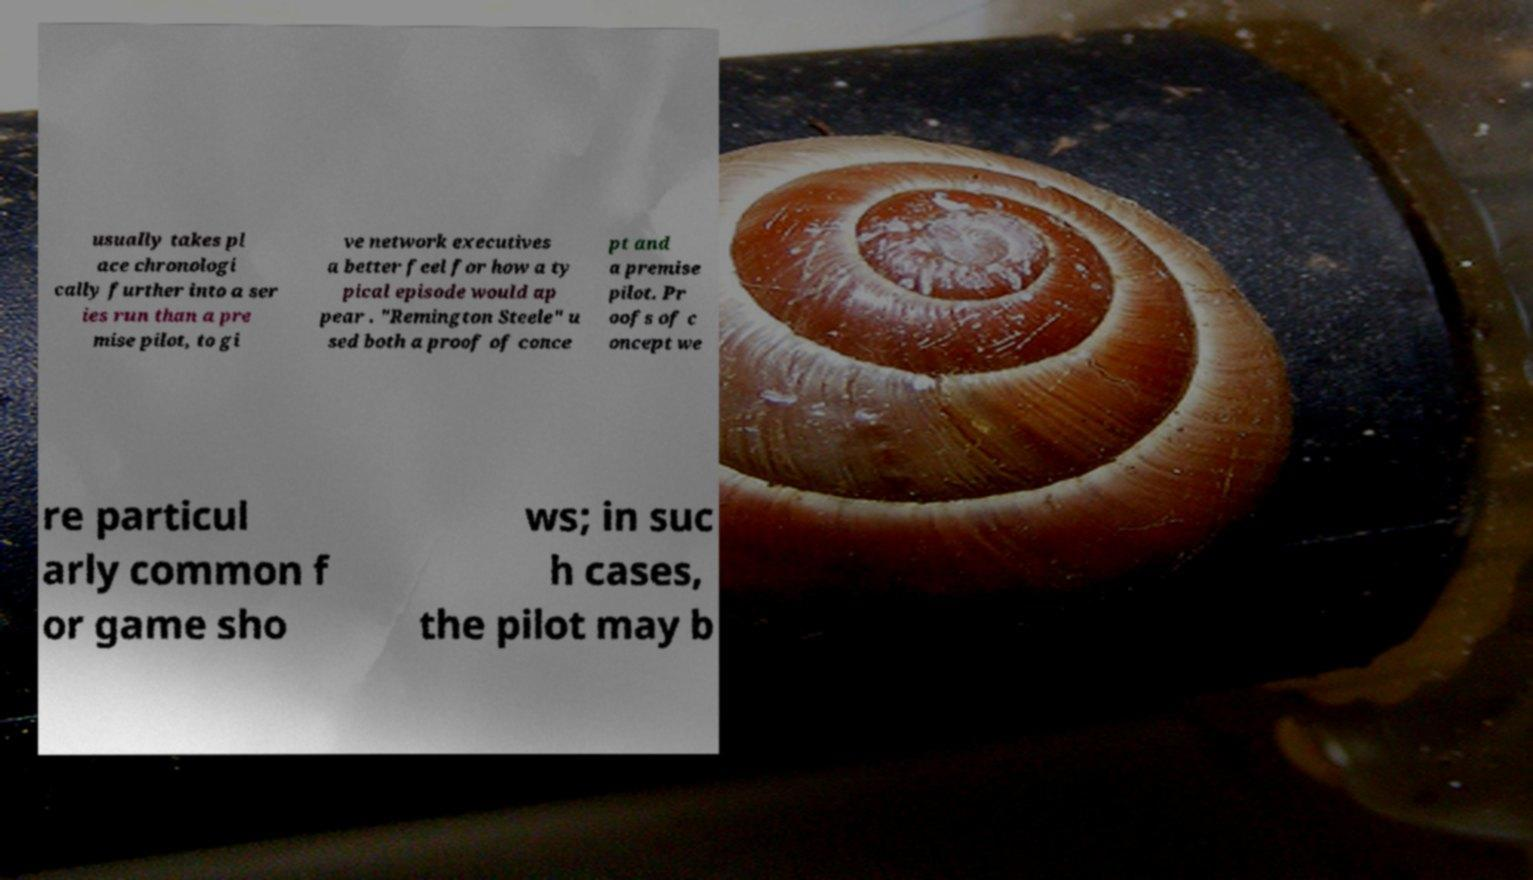Please read and relay the text visible in this image. What does it say? usually takes pl ace chronologi cally further into a ser ies run than a pre mise pilot, to gi ve network executives a better feel for how a ty pical episode would ap pear . "Remington Steele" u sed both a proof of conce pt and a premise pilot. Pr oofs of c oncept we re particul arly common f or game sho ws; in suc h cases, the pilot may b 